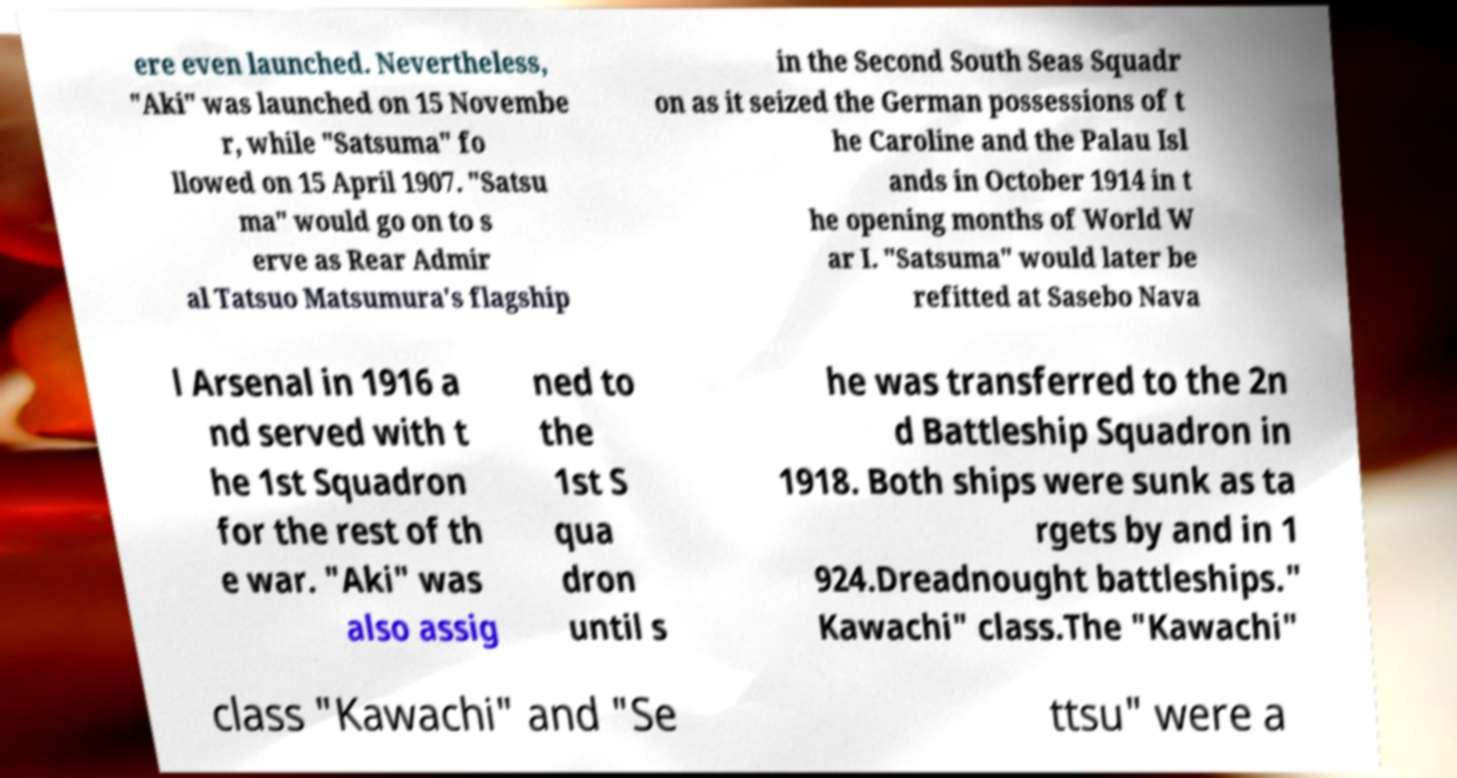I need the written content from this picture converted into text. Can you do that? ere even launched. Nevertheless, "Aki" was launched on 15 Novembe r, while "Satsuma" fo llowed on 15 April 1907. "Satsu ma" would go on to s erve as Rear Admir al Tatsuo Matsumura's flagship in the Second South Seas Squadr on as it seized the German possessions of t he Caroline and the Palau Isl ands in October 1914 in t he opening months of World W ar I. "Satsuma" would later be refitted at Sasebo Nava l Arsenal in 1916 a nd served with t he 1st Squadron for the rest of th e war. "Aki" was also assig ned to the 1st S qua dron until s he was transferred to the 2n d Battleship Squadron in 1918. Both ships were sunk as ta rgets by and in 1 924.Dreadnought battleships." Kawachi" class.The "Kawachi" class "Kawachi" and "Se ttsu" were a 